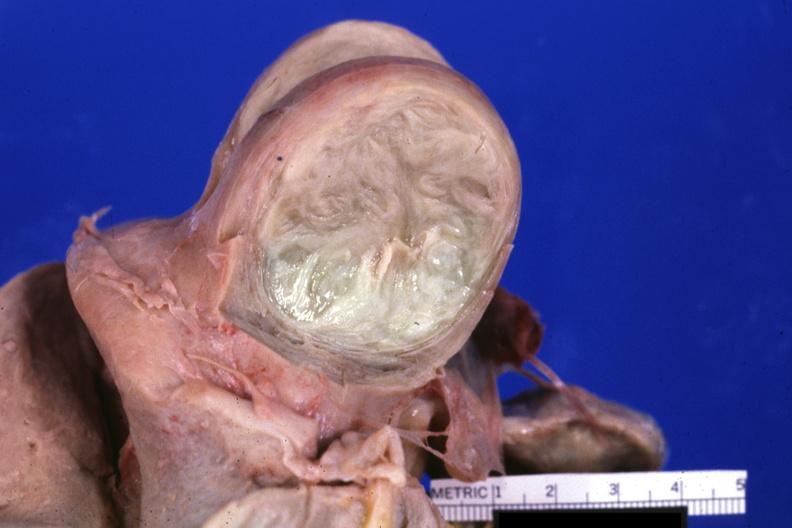what does this image show?
Answer the question using a single word or phrase. Fixed tissue cut surface of typical myoma 